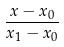Convert formula to latex. <formula><loc_0><loc_0><loc_500><loc_500>\frac { x - x _ { 0 } } { x _ { 1 } - x _ { 0 } }</formula> 